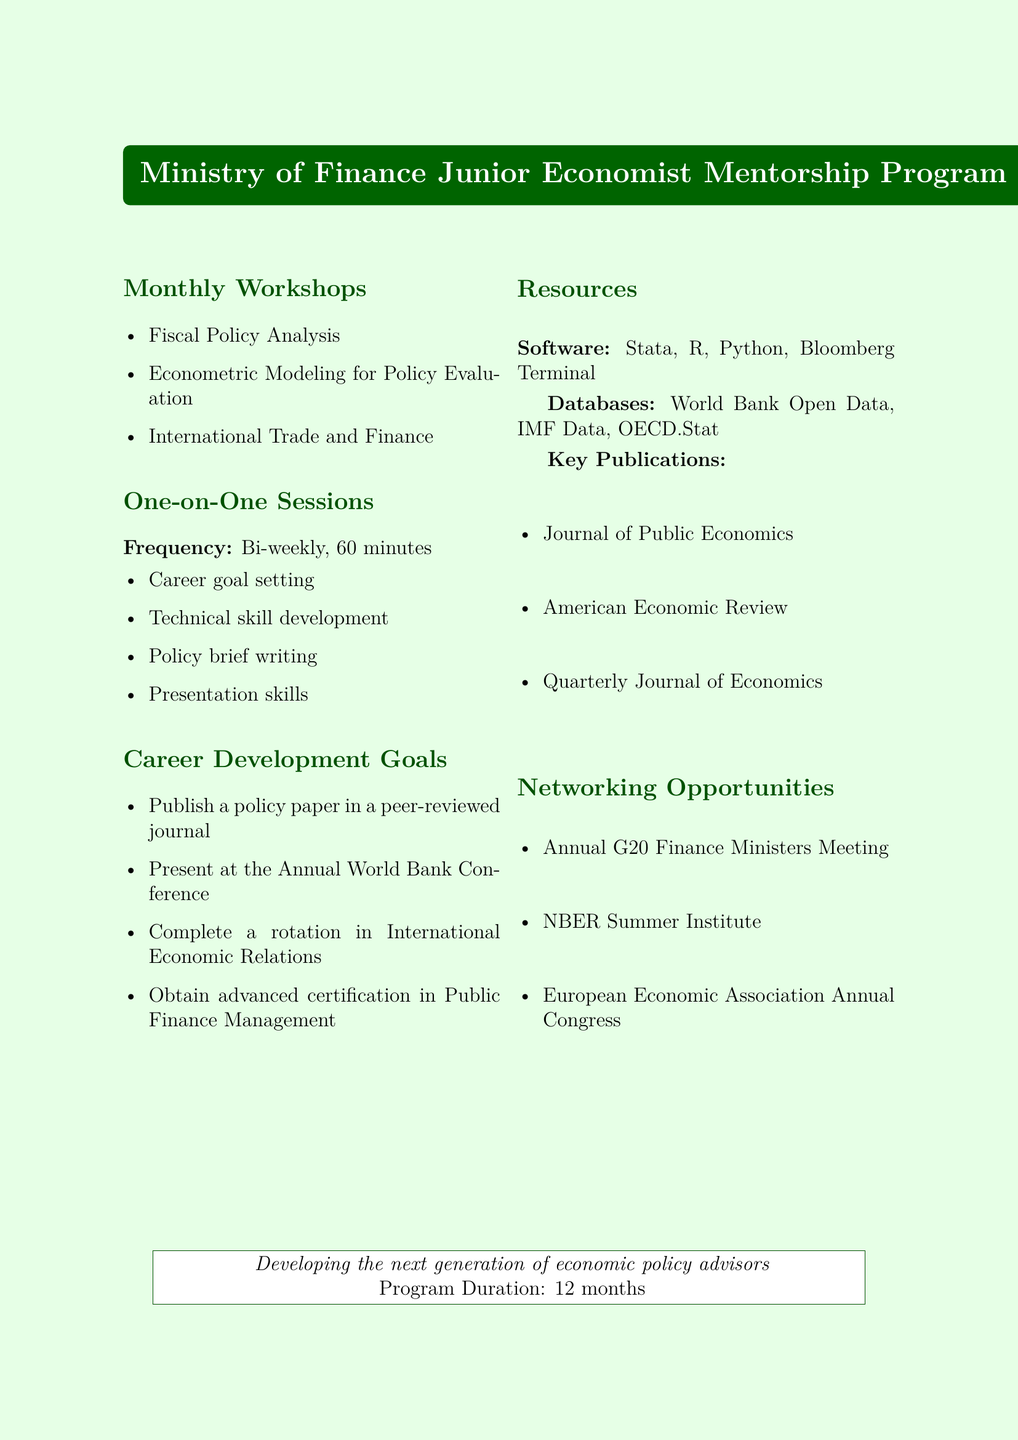what is the title of the program? The title is explicitly stated at the beginning of the document, which is "Ministry of Finance Junior Economist Mentorship Program."
Answer: Ministry of Finance Junior Economist Mentorship Program how long is the program duration? The program duration is directly mentioned in the overview section of the document.
Answer: 12 months who is the speaker for the workshop on "Econometric Modeling for Policy Evaluation"? This information is noted under the monthly workshops section, where each topic is paired with a speaker.
Answer: Prof. Angus Deaton how often are the one-on-one sessions held? The frequency of the one-on-one sessions is specified in the section about these sessions.
Answer: Bi-weekly what is one of the career development goals mentioned in the document? The goals are listed in the career development section, indicating specific objectives for junior economists.
Answer: Publish a policy paper in a peer-reviewed journal which software is included as a resource in the program? The resources section specifies the software tools that participants will have access to.
Answer: Stata name one of the networking opportunities provided in the program. The networking opportunities section lists events that can facilitate connections for participants.
Answer: Annual G20 Finance Ministers and Central Bank Governors Meeting what is the main goal of the mentorship program? The goal is articulated in the program overview and summarizes the purpose of the initiative for junior economists.
Answer: Develop the next generation of economic policy advisors 